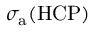Convert formula to latex. <formula><loc_0><loc_0><loc_500><loc_500>\sigma _ { a } ( { H C P } )</formula> 